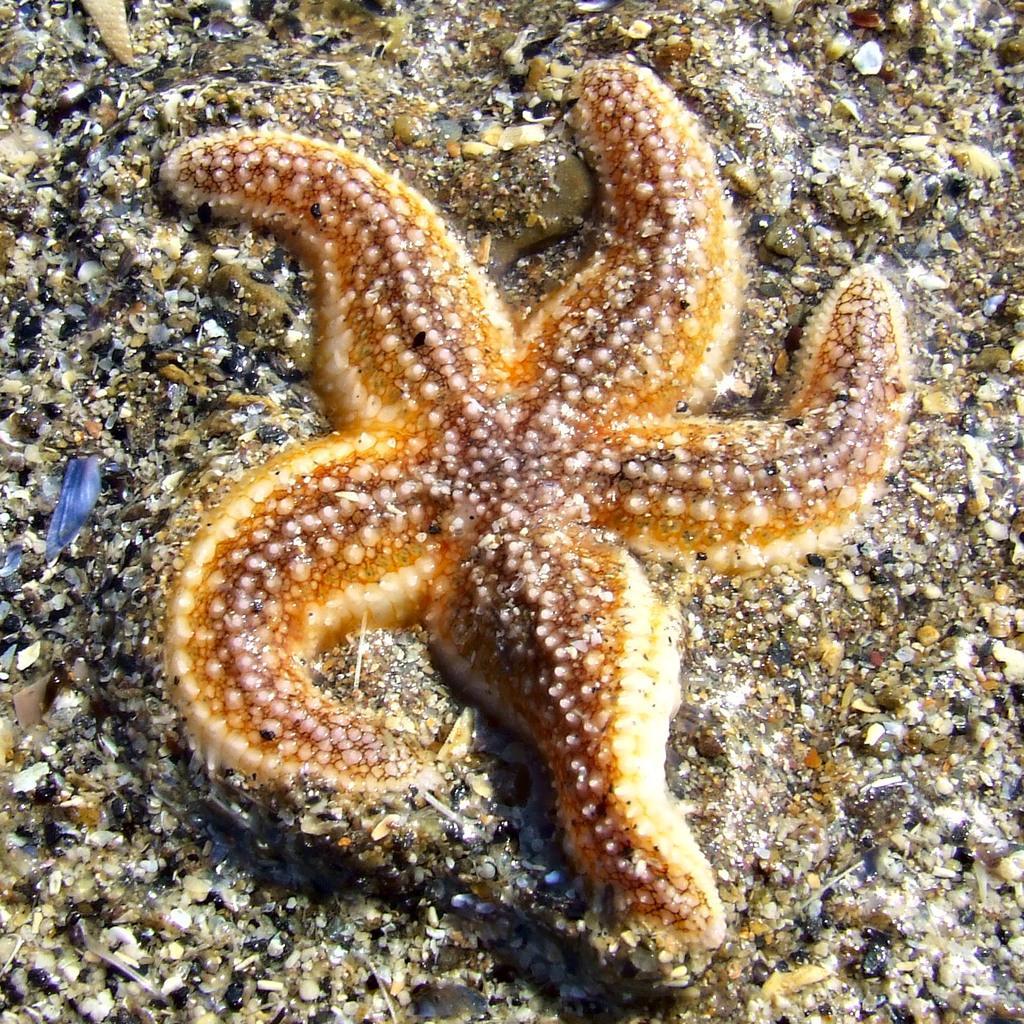How would you summarize this image in a sentence or two? In the image there is a starfish on the ground. On the ground there are small stones. 